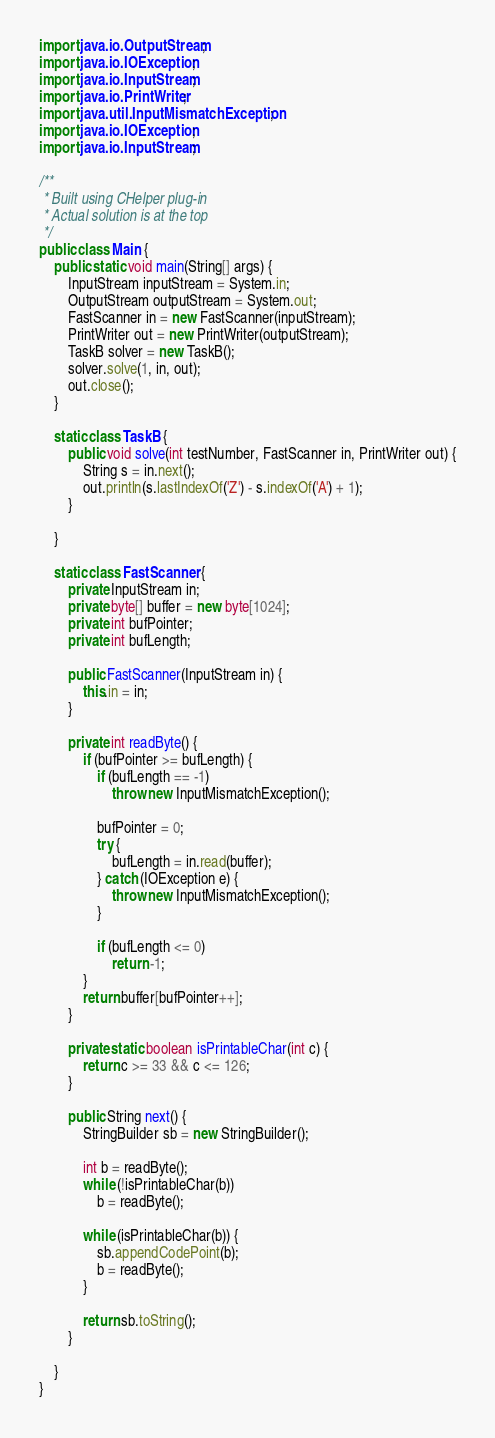Convert code to text. <code><loc_0><loc_0><loc_500><loc_500><_Java_>import java.io.OutputStream;
import java.io.IOException;
import java.io.InputStream;
import java.io.PrintWriter;
import java.util.InputMismatchException;
import java.io.IOException;
import java.io.InputStream;

/**
 * Built using CHelper plug-in
 * Actual solution is at the top
 */
public class Main {
    public static void main(String[] args) {
        InputStream inputStream = System.in;
        OutputStream outputStream = System.out;
        FastScanner in = new FastScanner(inputStream);
        PrintWriter out = new PrintWriter(outputStream);
        TaskB solver = new TaskB();
        solver.solve(1, in, out);
        out.close();
    }

    static class TaskB {
        public void solve(int testNumber, FastScanner in, PrintWriter out) {
            String s = in.next();
            out.println(s.lastIndexOf('Z') - s.indexOf('A') + 1);
        }

    }

    static class FastScanner {
        private InputStream in;
        private byte[] buffer = new byte[1024];
        private int bufPointer;
        private int bufLength;

        public FastScanner(InputStream in) {
            this.in = in;
        }

        private int readByte() {
            if (bufPointer >= bufLength) {
                if (bufLength == -1)
                    throw new InputMismatchException();

                bufPointer = 0;
                try {
                    bufLength = in.read(buffer);
                } catch (IOException e) {
                    throw new InputMismatchException();
                }

                if (bufLength <= 0)
                    return -1;
            }
            return buffer[bufPointer++];
        }

        private static boolean isPrintableChar(int c) {
            return c >= 33 && c <= 126;
        }

        public String next() {
            StringBuilder sb = new StringBuilder();

            int b = readByte();
            while (!isPrintableChar(b))
                b = readByte();

            while (isPrintableChar(b)) {
                sb.appendCodePoint(b);
                b = readByte();
            }

            return sb.toString();
        }

    }
}

</code> 